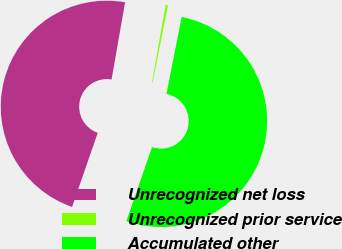Convert chart to OTSL. <chart><loc_0><loc_0><loc_500><loc_500><pie_chart><fcel>Unrecognized net loss<fcel>Unrecognized prior service<fcel>Accumulated other<nl><fcel>47.45%<fcel>0.35%<fcel>52.2%<nl></chart> 